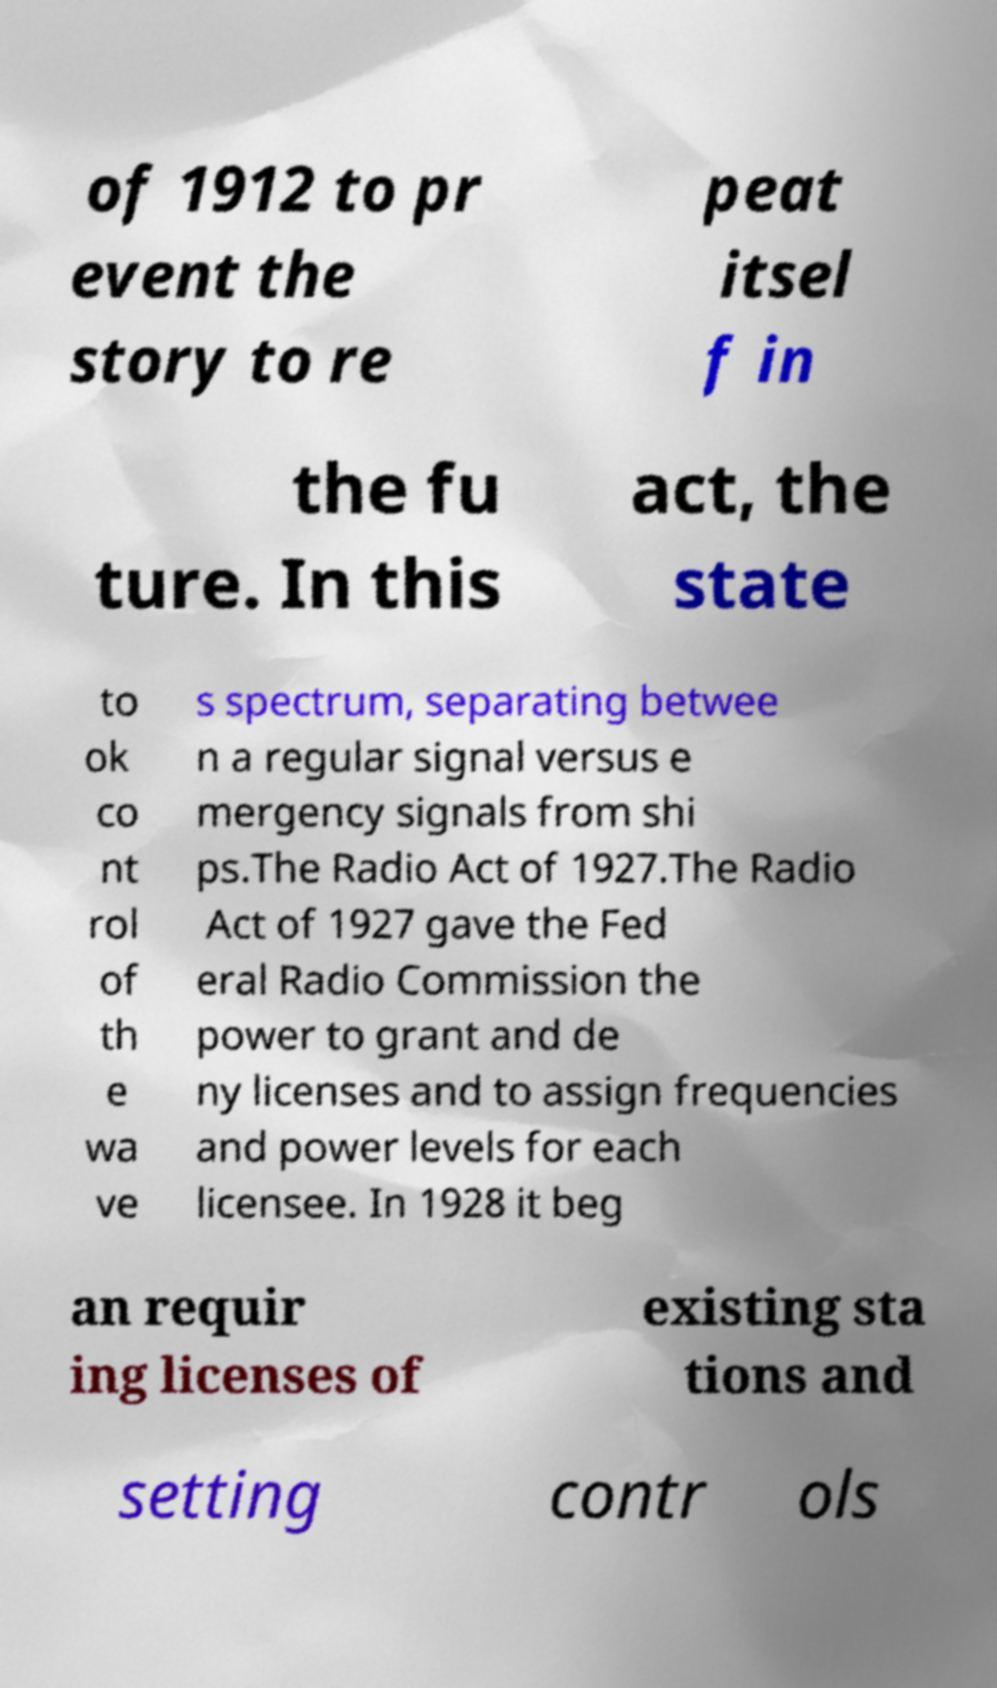Could you assist in decoding the text presented in this image and type it out clearly? of 1912 to pr event the story to re peat itsel f in the fu ture. In this act, the state to ok co nt rol of th e wa ve s spectrum, separating betwee n a regular signal versus e mergency signals from shi ps.The Radio Act of 1927.The Radio Act of 1927 gave the Fed eral Radio Commission the power to grant and de ny licenses and to assign frequencies and power levels for each licensee. In 1928 it beg an requir ing licenses of existing sta tions and setting contr ols 